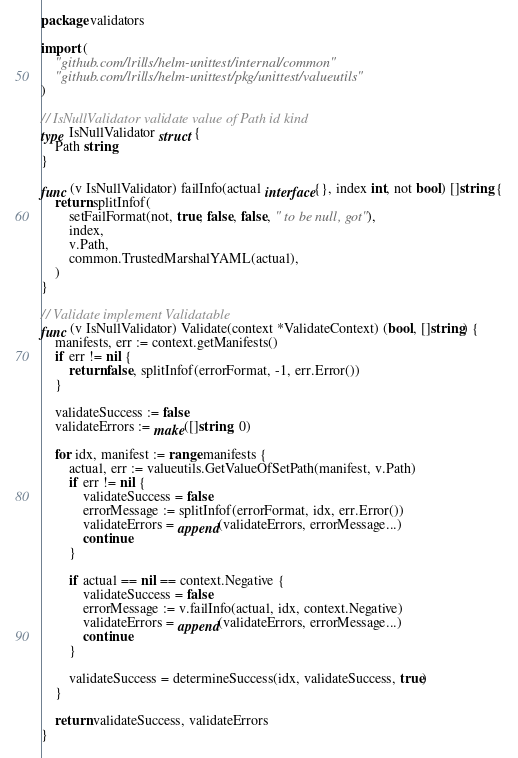<code> <loc_0><loc_0><loc_500><loc_500><_Go_>package validators

import (
	"github.com/lrills/helm-unittest/internal/common"
	"github.com/lrills/helm-unittest/pkg/unittest/valueutils"
)

// IsNullValidator validate value of Path id kind
type IsNullValidator struct {
	Path string
}

func (v IsNullValidator) failInfo(actual interface{}, index int, not bool) []string {
	return splitInfof(
		setFailFormat(not, true, false, false, " to be null, got"),
		index,
		v.Path,
		common.TrustedMarshalYAML(actual),
	)
}

// Validate implement Validatable
func (v IsNullValidator) Validate(context *ValidateContext) (bool, []string) {
	manifests, err := context.getManifests()
	if err != nil {
		return false, splitInfof(errorFormat, -1, err.Error())
	}

	validateSuccess := false
	validateErrors := make([]string, 0)

	for idx, manifest := range manifests {
		actual, err := valueutils.GetValueOfSetPath(manifest, v.Path)
		if err != nil {
			validateSuccess = false
			errorMessage := splitInfof(errorFormat, idx, err.Error())
			validateErrors = append(validateErrors, errorMessage...)
			continue
		}

		if actual == nil == context.Negative {
			validateSuccess = false
			errorMessage := v.failInfo(actual, idx, context.Negative)
			validateErrors = append(validateErrors, errorMessage...)
			continue
		}

		validateSuccess = determineSuccess(idx, validateSuccess, true)
	}

	return validateSuccess, validateErrors
}
</code> 